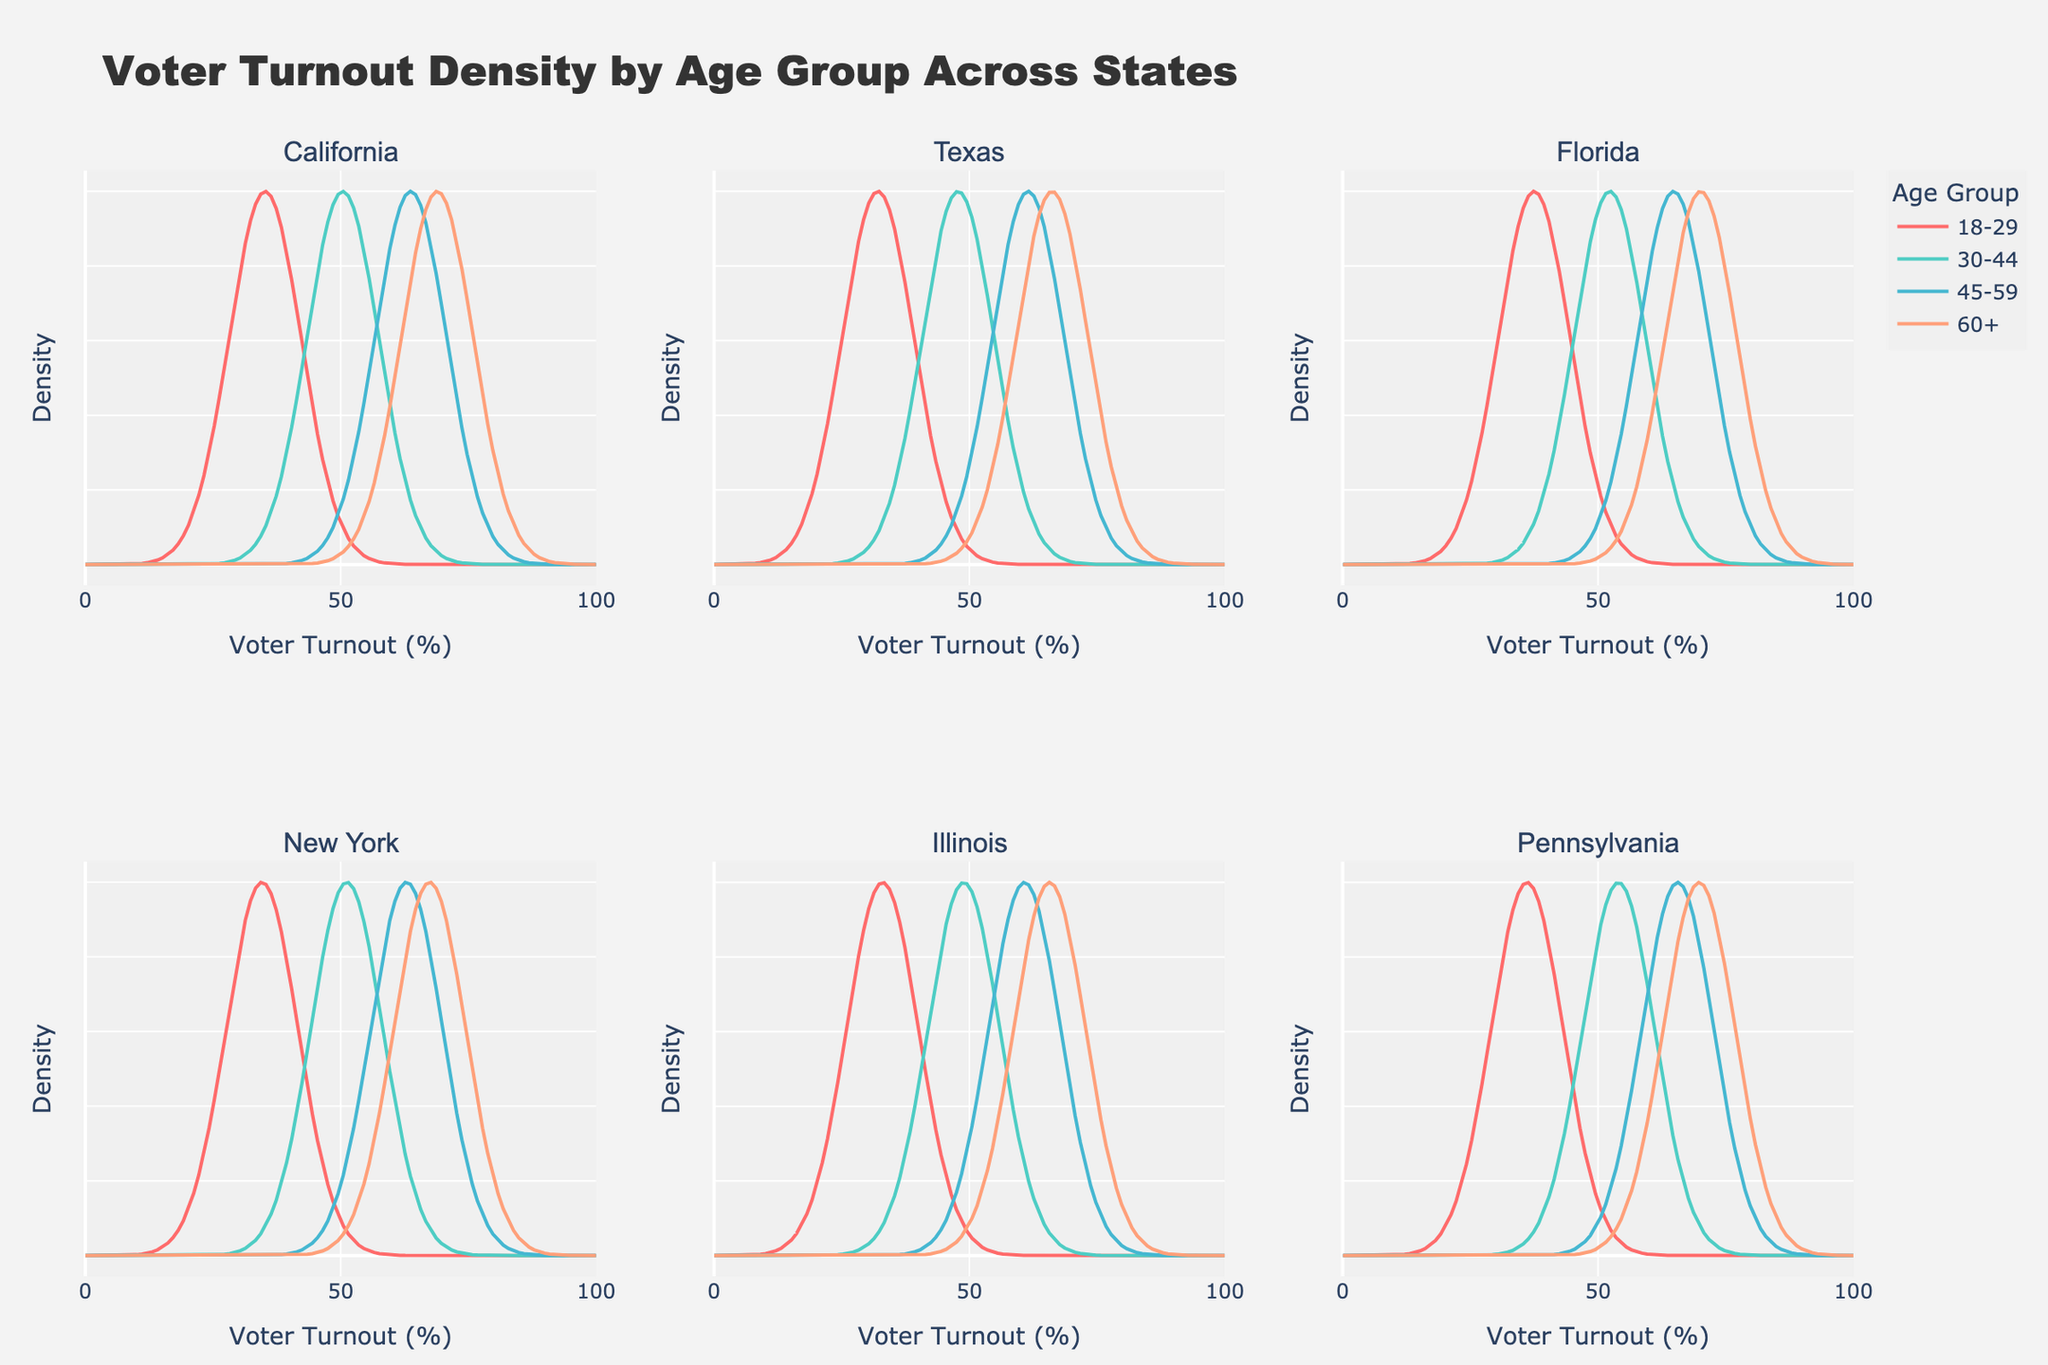What's the title of the figure? The title is written at the top of the figure which provides an overall description of the plot's content.
Answer: Voter Turnout Density by Age Group Across States Which age group is represented by red curves? The color legend in the figure shows that the red curves represent a specific age group.
Answer: 18-29 What age group has the highest voter turnout in Texas? By identifying the highest peak of the density curves in the subplot for Texas, we can determine the age group with the highest voter turnout. The peak density represents the most common voter turnout for that age group.
Answer: 60+ Are voter turnout rates higher in Pennsylvania or Illinois for the 45-59 age group? Compare the peaks of the density curves representing the 45-59 age group in the subplots for Pennsylvania and Illinois. The state with the higher peak in density indicates a higher voter turnout.
Answer: Pennsylvania Which state has the lowest voter turnout for the 18-29 age group? Identify the 18-29 age group's peaks in each state's subplot and find the state where the peak is at the lowest value along the x-axis.
Answer: Texas How does voter turnout for the 60+ age group in California compare with that in Florida? Compare the density curves for the 60+ age group between California and Florida's subplots. Evaluate which state has the higher peak density for this age group.
Answer: Florida What is the general trend of voter turnout rates across different age groups? Analyze the density curves for each age group across all subplots. Observe if the peaks shift rightwards (higher turnout) as age increases.
Answer: Turnout increases with age Which age group has the most consistent voter turnout across the states? Examine the density curves for each age group across all subplots. The age group with the density peaks occurring at similar voter turnout values across most states is the most consistent.
Answer: 60+ What is the voter turnout rate for the 30-44 age group in New York? Locate the peak density value for the 30-44 age group in the subplot for New York. The x-axis value at the peak is the voter turnout rate.
Answer: 51.2% Which state has the highest turnout rate for the 18-29 age group based on the peaks of the density curves? Compare the peaks of the density curves for the 18-29 age group across all state subplots and identify the highest peak.
Answer: Florida 